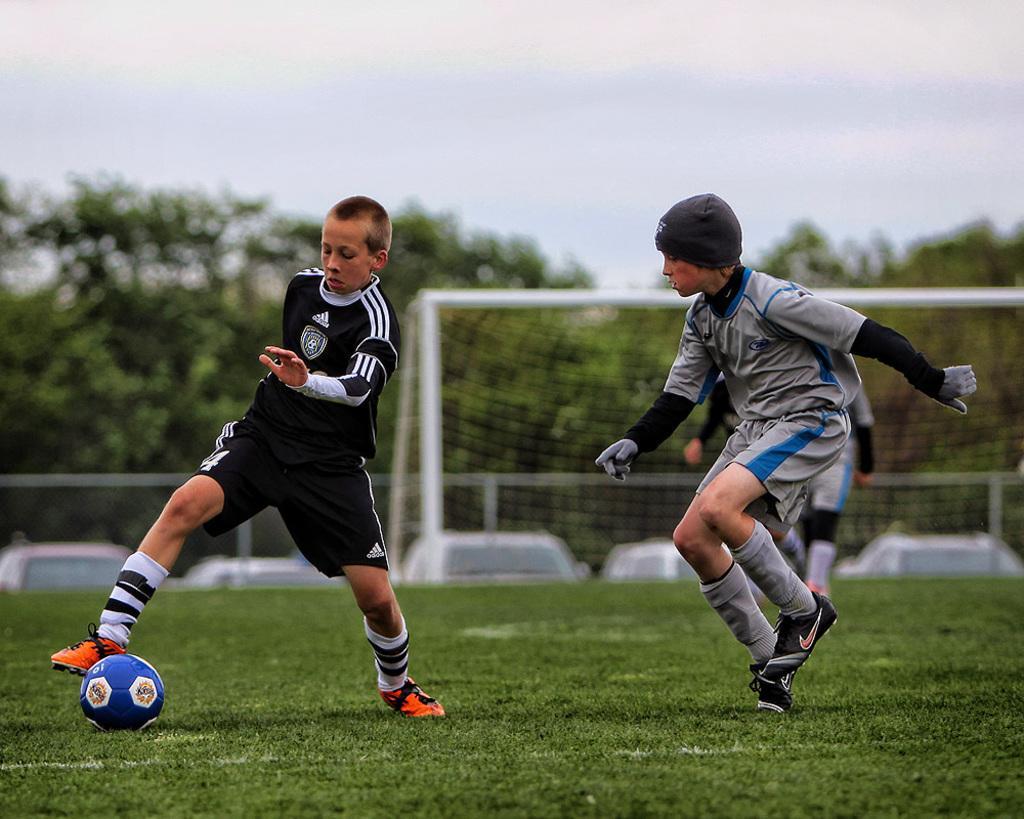How would you summarize this image in a sentence or two? In the given image we can see there are three boys playing. This is a ball, grass, court, vehicle, trees and sky. 